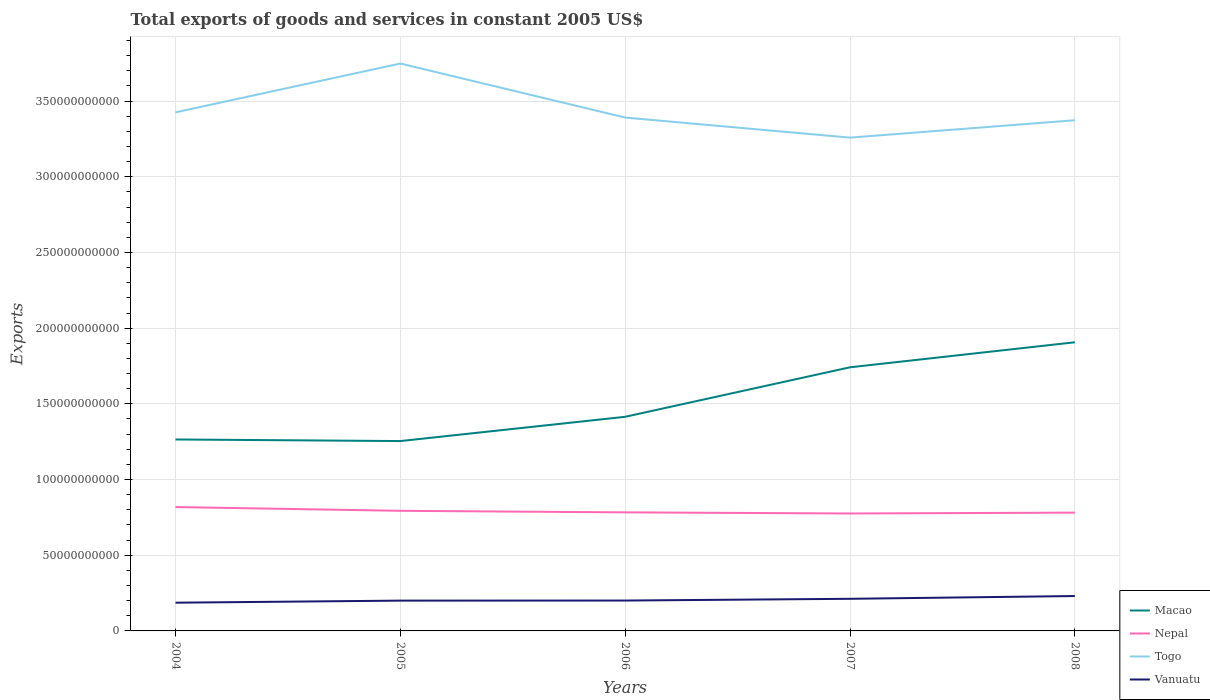Is the number of lines equal to the number of legend labels?
Your answer should be compact. Yes. Across all years, what is the maximum total exports of goods and services in Nepal?
Make the answer very short. 7.76e+1. In which year was the total exports of goods and services in Nepal maximum?
Keep it short and to the point. 2007. What is the total total exports of goods and services in Togo in the graph?
Ensure brevity in your answer.  1.33e+1. What is the difference between the highest and the second highest total exports of goods and services in Nepal?
Your response must be concise. 4.25e+09. What is the difference between the highest and the lowest total exports of goods and services in Vanuatu?
Provide a succinct answer. 2. How many years are there in the graph?
Offer a terse response. 5. What is the difference between two consecutive major ticks on the Y-axis?
Your answer should be very brief. 5.00e+1. Does the graph contain any zero values?
Provide a short and direct response. No. Where does the legend appear in the graph?
Offer a very short reply. Bottom right. How are the legend labels stacked?
Offer a very short reply. Vertical. What is the title of the graph?
Keep it short and to the point. Total exports of goods and services in constant 2005 US$. What is the label or title of the Y-axis?
Offer a terse response. Exports. What is the Exports of Macao in 2004?
Your response must be concise. 1.26e+11. What is the Exports of Nepal in 2004?
Provide a short and direct response. 8.18e+1. What is the Exports of Togo in 2004?
Make the answer very short. 3.43e+11. What is the Exports in Vanuatu in 2004?
Offer a terse response. 1.86e+1. What is the Exports of Macao in 2005?
Offer a very short reply. 1.25e+11. What is the Exports of Nepal in 2005?
Keep it short and to the point. 7.93e+1. What is the Exports in Togo in 2005?
Your answer should be compact. 3.75e+11. What is the Exports of Vanuatu in 2005?
Offer a very short reply. 2.00e+1. What is the Exports of Macao in 2006?
Your answer should be very brief. 1.41e+11. What is the Exports of Nepal in 2006?
Your answer should be compact. 7.83e+1. What is the Exports in Togo in 2006?
Provide a succinct answer. 3.39e+11. What is the Exports in Vanuatu in 2006?
Give a very brief answer. 2.01e+1. What is the Exports in Macao in 2007?
Ensure brevity in your answer.  1.74e+11. What is the Exports in Nepal in 2007?
Offer a very short reply. 7.76e+1. What is the Exports of Togo in 2007?
Your response must be concise. 3.26e+11. What is the Exports of Vanuatu in 2007?
Keep it short and to the point. 2.12e+1. What is the Exports of Macao in 2008?
Offer a terse response. 1.91e+11. What is the Exports of Nepal in 2008?
Provide a succinct answer. 7.81e+1. What is the Exports in Togo in 2008?
Offer a terse response. 3.37e+11. What is the Exports in Vanuatu in 2008?
Your answer should be very brief. 2.31e+1. Across all years, what is the maximum Exports of Macao?
Your response must be concise. 1.91e+11. Across all years, what is the maximum Exports in Nepal?
Your response must be concise. 8.18e+1. Across all years, what is the maximum Exports in Togo?
Make the answer very short. 3.75e+11. Across all years, what is the maximum Exports of Vanuatu?
Give a very brief answer. 2.31e+1. Across all years, what is the minimum Exports of Macao?
Offer a very short reply. 1.25e+11. Across all years, what is the minimum Exports of Nepal?
Provide a short and direct response. 7.76e+1. Across all years, what is the minimum Exports of Togo?
Offer a very short reply. 3.26e+11. Across all years, what is the minimum Exports in Vanuatu?
Your answer should be compact. 1.86e+1. What is the total Exports of Macao in the graph?
Your answer should be compact. 7.58e+11. What is the total Exports in Nepal in the graph?
Your response must be concise. 3.95e+11. What is the total Exports in Togo in the graph?
Make the answer very short. 1.72e+12. What is the total Exports of Vanuatu in the graph?
Your answer should be very brief. 1.03e+11. What is the difference between the Exports in Macao in 2004 and that in 2005?
Provide a succinct answer. 1.05e+09. What is the difference between the Exports in Nepal in 2004 and that in 2005?
Ensure brevity in your answer.  2.48e+09. What is the difference between the Exports in Togo in 2004 and that in 2005?
Make the answer very short. -3.22e+1. What is the difference between the Exports in Vanuatu in 2004 and that in 2005?
Your answer should be very brief. -1.37e+09. What is the difference between the Exports in Macao in 2004 and that in 2006?
Give a very brief answer. -1.50e+1. What is the difference between the Exports of Nepal in 2004 and that in 2006?
Make the answer very short. 3.51e+09. What is the difference between the Exports in Togo in 2004 and that in 2006?
Your answer should be very brief. 3.45e+09. What is the difference between the Exports in Vanuatu in 2004 and that in 2006?
Offer a terse response. -1.42e+09. What is the difference between the Exports of Macao in 2004 and that in 2007?
Provide a short and direct response. -4.77e+1. What is the difference between the Exports in Nepal in 2004 and that in 2007?
Provide a succinct answer. 4.25e+09. What is the difference between the Exports of Togo in 2004 and that in 2007?
Your answer should be compact. 1.67e+1. What is the difference between the Exports in Vanuatu in 2004 and that in 2007?
Offer a terse response. -2.58e+09. What is the difference between the Exports in Macao in 2004 and that in 2008?
Your answer should be very brief. -6.42e+1. What is the difference between the Exports of Nepal in 2004 and that in 2008?
Give a very brief answer. 3.69e+09. What is the difference between the Exports of Togo in 2004 and that in 2008?
Give a very brief answer. 5.23e+09. What is the difference between the Exports of Vanuatu in 2004 and that in 2008?
Ensure brevity in your answer.  -4.40e+09. What is the difference between the Exports of Macao in 2005 and that in 2006?
Offer a terse response. -1.60e+1. What is the difference between the Exports of Nepal in 2005 and that in 2006?
Your answer should be very brief. 1.03e+09. What is the difference between the Exports in Togo in 2005 and that in 2006?
Ensure brevity in your answer.  3.57e+1. What is the difference between the Exports of Vanuatu in 2005 and that in 2006?
Make the answer very short. -5.00e+07. What is the difference between the Exports of Macao in 2005 and that in 2007?
Provide a short and direct response. -4.87e+1. What is the difference between the Exports of Nepal in 2005 and that in 2007?
Your answer should be compact. 1.77e+09. What is the difference between the Exports of Togo in 2005 and that in 2007?
Your response must be concise. 4.90e+1. What is the difference between the Exports in Vanuatu in 2005 and that in 2007?
Provide a short and direct response. -1.21e+09. What is the difference between the Exports of Macao in 2005 and that in 2008?
Ensure brevity in your answer.  -6.53e+1. What is the difference between the Exports of Nepal in 2005 and that in 2008?
Your answer should be very brief. 1.20e+09. What is the difference between the Exports of Togo in 2005 and that in 2008?
Your answer should be compact. 3.75e+1. What is the difference between the Exports in Vanuatu in 2005 and that in 2008?
Offer a very short reply. -3.04e+09. What is the difference between the Exports of Macao in 2006 and that in 2007?
Make the answer very short. -3.27e+1. What is the difference between the Exports of Nepal in 2006 and that in 2007?
Make the answer very short. 7.40e+08. What is the difference between the Exports in Togo in 2006 and that in 2007?
Keep it short and to the point. 1.33e+1. What is the difference between the Exports in Vanuatu in 2006 and that in 2007?
Provide a short and direct response. -1.16e+09. What is the difference between the Exports in Macao in 2006 and that in 2008?
Your response must be concise. -4.92e+1. What is the difference between the Exports of Nepal in 2006 and that in 2008?
Your response must be concise. 1.76e+08. What is the difference between the Exports of Togo in 2006 and that in 2008?
Your response must be concise. 1.77e+09. What is the difference between the Exports in Vanuatu in 2006 and that in 2008?
Offer a very short reply. -2.99e+09. What is the difference between the Exports of Macao in 2007 and that in 2008?
Give a very brief answer. -1.65e+1. What is the difference between the Exports in Nepal in 2007 and that in 2008?
Offer a very short reply. -5.64e+08. What is the difference between the Exports of Togo in 2007 and that in 2008?
Give a very brief answer. -1.15e+1. What is the difference between the Exports in Vanuatu in 2007 and that in 2008?
Offer a very short reply. -1.83e+09. What is the difference between the Exports of Macao in 2004 and the Exports of Nepal in 2005?
Keep it short and to the point. 4.71e+1. What is the difference between the Exports of Macao in 2004 and the Exports of Togo in 2005?
Your response must be concise. -2.48e+11. What is the difference between the Exports of Macao in 2004 and the Exports of Vanuatu in 2005?
Offer a terse response. 1.06e+11. What is the difference between the Exports in Nepal in 2004 and the Exports in Togo in 2005?
Provide a succinct answer. -2.93e+11. What is the difference between the Exports in Nepal in 2004 and the Exports in Vanuatu in 2005?
Your answer should be compact. 6.18e+1. What is the difference between the Exports of Togo in 2004 and the Exports of Vanuatu in 2005?
Provide a short and direct response. 3.23e+11. What is the difference between the Exports in Macao in 2004 and the Exports in Nepal in 2006?
Offer a terse response. 4.82e+1. What is the difference between the Exports in Macao in 2004 and the Exports in Togo in 2006?
Your response must be concise. -2.13e+11. What is the difference between the Exports of Macao in 2004 and the Exports of Vanuatu in 2006?
Give a very brief answer. 1.06e+11. What is the difference between the Exports of Nepal in 2004 and the Exports of Togo in 2006?
Make the answer very short. -2.57e+11. What is the difference between the Exports of Nepal in 2004 and the Exports of Vanuatu in 2006?
Provide a short and direct response. 6.18e+1. What is the difference between the Exports of Togo in 2004 and the Exports of Vanuatu in 2006?
Offer a very short reply. 3.23e+11. What is the difference between the Exports of Macao in 2004 and the Exports of Nepal in 2007?
Offer a terse response. 4.89e+1. What is the difference between the Exports in Macao in 2004 and the Exports in Togo in 2007?
Keep it short and to the point. -1.99e+11. What is the difference between the Exports in Macao in 2004 and the Exports in Vanuatu in 2007?
Offer a very short reply. 1.05e+11. What is the difference between the Exports of Nepal in 2004 and the Exports of Togo in 2007?
Provide a succinct answer. -2.44e+11. What is the difference between the Exports of Nepal in 2004 and the Exports of Vanuatu in 2007?
Offer a terse response. 6.06e+1. What is the difference between the Exports of Togo in 2004 and the Exports of Vanuatu in 2007?
Keep it short and to the point. 3.21e+11. What is the difference between the Exports in Macao in 2004 and the Exports in Nepal in 2008?
Your answer should be compact. 4.83e+1. What is the difference between the Exports in Macao in 2004 and the Exports in Togo in 2008?
Ensure brevity in your answer.  -2.11e+11. What is the difference between the Exports in Macao in 2004 and the Exports in Vanuatu in 2008?
Your response must be concise. 1.03e+11. What is the difference between the Exports in Nepal in 2004 and the Exports in Togo in 2008?
Make the answer very short. -2.56e+11. What is the difference between the Exports in Nepal in 2004 and the Exports in Vanuatu in 2008?
Your answer should be very brief. 5.88e+1. What is the difference between the Exports of Togo in 2004 and the Exports of Vanuatu in 2008?
Your answer should be compact. 3.20e+11. What is the difference between the Exports of Macao in 2005 and the Exports of Nepal in 2006?
Provide a succinct answer. 4.71e+1. What is the difference between the Exports in Macao in 2005 and the Exports in Togo in 2006?
Offer a very short reply. -2.14e+11. What is the difference between the Exports in Macao in 2005 and the Exports in Vanuatu in 2006?
Provide a short and direct response. 1.05e+11. What is the difference between the Exports of Nepal in 2005 and the Exports of Togo in 2006?
Keep it short and to the point. -2.60e+11. What is the difference between the Exports of Nepal in 2005 and the Exports of Vanuatu in 2006?
Your answer should be compact. 5.93e+1. What is the difference between the Exports of Togo in 2005 and the Exports of Vanuatu in 2006?
Provide a short and direct response. 3.55e+11. What is the difference between the Exports in Macao in 2005 and the Exports in Nepal in 2007?
Your answer should be very brief. 4.78e+1. What is the difference between the Exports in Macao in 2005 and the Exports in Togo in 2007?
Offer a very short reply. -2.00e+11. What is the difference between the Exports of Macao in 2005 and the Exports of Vanuatu in 2007?
Keep it short and to the point. 1.04e+11. What is the difference between the Exports of Nepal in 2005 and the Exports of Togo in 2007?
Give a very brief answer. -2.47e+11. What is the difference between the Exports of Nepal in 2005 and the Exports of Vanuatu in 2007?
Ensure brevity in your answer.  5.81e+1. What is the difference between the Exports of Togo in 2005 and the Exports of Vanuatu in 2007?
Provide a short and direct response. 3.54e+11. What is the difference between the Exports of Macao in 2005 and the Exports of Nepal in 2008?
Offer a very short reply. 4.73e+1. What is the difference between the Exports in Macao in 2005 and the Exports in Togo in 2008?
Your response must be concise. -2.12e+11. What is the difference between the Exports of Macao in 2005 and the Exports of Vanuatu in 2008?
Offer a terse response. 1.02e+11. What is the difference between the Exports in Nepal in 2005 and the Exports in Togo in 2008?
Keep it short and to the point. -2.58e+11. What is the difference between the Exports of Nepal in 2005 and the Exports of Vanuatu in 2008?
Provide a short and direct response. 5.63e+1. What is the difference between the Exports in Togo in 2005 and the Exports in Vanuatu in 2008?
Keep it short and to the point. 3.52e+11. What is the difference between the Exports of Macao in 2006 and the Exports of Nepal in 2007?
Your response must be concise. 6.39e+1. What is the difference between the Exports of Macao in 2006 and the Exports of Togo in 2007?
Make the answer very short. -1.84e+11. What is the difference between the Exports of Macao in 2006 and the Exports of Vanuatu in 2007?
Your response must be concise. 1.20e+11. What is the difference between the Exports in Nepal in 2006 and the Exports in Togo in 2007?
Ensure brevity in your answer.  -2.48e+11. What is the difference between the Exports in Nepal in 2006 and the Exports in Vanuatu in 2007?
Make the answer very short. 5.71e+1. What is the difference between the Exports of Togo in 2006 and the Exports of Vanuatu in 2007?
Make the answer very short. 3.18e+11. What is the difference between the Exports of Macao in 2006 and the Exports of Nepal in 2008?
Your response must be concise. 6.33e+1. What is the difference between the Exports of Macao in 2006 and the Exports of Togo in 2008?
Your answer should be very brief. -1.96e+11. What is the difference between the Exports in Macao in 2006 and the Exports in Vanuatu in 2008?
Make the answer very short. 1.18e+11. What is the difference between the Exports in Nepal in 2006 and the Exports in Togo in 2008?
Your answer should be very brief. -2.59e+11. What is the difference between the Exports in Nepal in 2006 and the Exports in Vanuatu in 2008?
Your answer should be compact. 5.53e+1. What is the difference between the Exports in Togo in 2006 and the Exports in Vanuatu in 2008?
Keep it short and to the point. 3.16e+11. What is the difference between the Exports in Macao in 2007 and the Exports in Nepal in 2008?
Ensure brevity in your answer.  9.60e+1. What is the difference between the Exports in Macao in 2007 and the Exports in Togo in 2008?
Give a very brief answer. -1.63e+11. What is the difference between the Exports of Macao in 2007 and the Exports of Vanuatu in 2008?
Provide a short and direct response. 1.51e+11. What is the difference between the Exports of Nepal in 2007 and the Exports of Togo in 2008?
Keep it short and to the point. -2.60e+11. What is the difference between the Exports of Nepal in 2007 and the Exports of Vanuatu in 2008?
Offer a terse response. 5.45e+1. What is the difference between the Exports in Togo in 2007 and the Exports in Vanuatu in 2008?
Your response must be concise. 3.03e+11. What is the average Exports of Macao per year?
Provide a succinct answer. 1.52e+11. What is the average Exports of Nepal per year?
Keep it short and to the point. 7.90e+1. What is the average Exports in Togo per year?
Make the answer very short. 3.44e+11. What is the average Exports in Vanuatu per year?
Make the answer very short. 2.06e+1. In the year 2004, what is the difference between the Exports in Macao and Exports in Nepal?
Keep it short and to the point. 4.46e+1. In the year 2004, what is the difference between the Exports in Macao and Exports in Togo?
Provide a succinct answer. -2.16e+11. In the year 2004, what is the difference between the Exports in Macao and Exports in Vanuatu?
Offer a terse response. 1.08e+11. In the year 2004, what is the difference between the Exports in Nepal and Exports in Togo?
Keep it short and to the point. -2.61e+11. In the year 2004, what is the difference between the Exports of Nepal and Exports of Vanuatu?
Make the answer very short. 6.32e+1. In the year 2004, what is the difference between the Exports of Togo and Exports of Vanuatu?
Give a very brief answer. 3.24e+11. In the year 2005, what is the difference between the Exports of Macao and Exports of Nepal?
Offer a terse response. 4.61e+1. In the year 2005, what is the difference between the Exports in Macao and Exports in Togo?
Provide a short and direct response. -2.49e+11. In the year 2005, what is the difference between the Exports of Macao and Exports of Vanuatu?
Offer a very short reply. 1.05e+11. In the year 2005, what is the difference between the Exports in Nepal and Exports in Togo?
Provide a succinct answer. -2.95e+11. In the year 2005, what is the difference between the Exports in Nepal and Exports in Vanuatu?
Provide a short and direct response. 5.93e+1. In the year 2005, what is the difference between the Exports in Togo and Exports in Vanuatu?
Ensure brevity in your answer.  3.55e+11. In the year 2006, what is the difference between the Exports of Macao and Exports of Nepal?
Provide a succinct answer. 6.31e+1. In the year 2006, what is the difference between the Exports in Macao and Exports in Togo?
Offer a terse response. -1.98e+11. In the year 2006, what is the difference between the Exports of Macao and Exports of Vanuatu?
Your response must be concise. 1.21e+11. In the year 2006, what is the difference between the Exports of Nepal and Exports of Togo?
Keep it short and to the point. -2.61e+11. In the year 2006, what is the difference between the Exports of Nepal and Exports of Vanuatu?
Offer a very short reply. 5.83e+1. In the year 2006, what is the difference between the Exports in Togo and Exports in Vanuatu?
Your answer should be compact. 3.19e+11. In the year 2007, what is the difference between the Exports in Macao and Exports in Nepal?
Provide a short and direct response. 9.66e+1. In the year 2007, what is the difference between the Exports of Macao and Exports of Togo?
Give a very brief answer. -1.52e+11. In the year 2007, what is the difference between the Exports in Macao and Exports in Vanuatu?
Keep it short and to the point. 1.53e+11. In the year 2007, what is the difference between the Exports in Nepal and Exports in Togo?
Offer a terse response. -2.48e+11. In the year 2007, what is the difference between the Exports of Nepal and Exports of Vanuatu?
Provide a short and direct response. 5.64e+1. In the year 2007, what is the difference between the Exports in Togo and Exports in Vanuatu?
Provide a succinct answer. 3.05e+11. In the year 2008, what is the difference between the Exports in Macao and Exports in Nepal?
Offer a very short reply. 1.13e+11. In the year 2008, what is the difference between the Exports in Macao and Exports in Togo?
Offer a terse response. -1.47e+11. In the year 2008, what is the difference between the Exports of Macao and Exports of Vanuatu?
Your answer should be very brief. 1.68e+11. In the year 2008, what is the difference between the Exports of Nepal and Exports of Togo?
Your response must be concise. -2.59e+11. In the year 2008, what is the difference between the Exports in Nepal and Exports in Vanuatu?
Ensure brevity in your answer.  5.51e+1. In the year 2008, what is the difference between the Exports in Togo and Exports in Vanuatu?
Provide a succinct answer. 3.14e+11. What is the ratio of the Exports of Macao in 2004 to that in 2005?
Your response must be concise. 1.01. What is the ratio of the Exports in Nepal in 2004 to that in 2005?
Your answer should be compact. 1.03. What is the ratio of the Exports of Togo in 2004 to that in 2005?
Make the answer very short. 0.91. What is the ratio of the Exports of Vanuatu in 2004 to that in 2005?
Your response must be concise. 0.93. What is the ratio of the Exports of Macao in 2004 to that in 2006?
Ensure brevity in your answer.  0.89. What is the ratio of the Exports in Nepal in 2004 to that in 2006?
Your response must be concise. 1.04. What is the ratio of the Exports of Togo in 2004 to that in 2006?
Provide a short and direct response. 1.01. What is the ratio of the Exports of Vanuatu in 2004 to that in 2006?
Make the answer very short. 0.93. What is the ratio of the Exports in Macao in 2004 to that in 2007?
Keep it short and to the point. 0.73. What is the ratio of the Exports in Nepal in 2004 to that in 2007?
Ensure brevity in your answer.  1.05. What is the ratio of the Exports in Togo in 2004 to that in 2007?
Make the answer very short. 1.05. What is the ratio of the Exports in Vanuatu in 2004 to that in 2007?
Your answer should be compact. 0.88. What is the ratio of the Exports in Macao in 2004 to that in 2008?
Give a very brief answer. 0.66. What is the ratio of the Exports of Nepal in 2004 to that in 2008?
Your answer should be very brief. 1.05. What is the ratio of the Exports of Togo in 2004 to that in 2008?
Provide a short and direct response. 1.02. What is the ratio of the Exports of Vanuatu in 2004 to that in 2008?
Provide a short and direct response. 0.81. What is the ratio of the Exports of Macao in 2005 to that in 2006?
Your answer should be very brief. 0.89. What is the ratio of the Exports in Nepal in 2005 to that in 2006?
Give a very brief answer. 1.01. What is the ratio of the Exports of Togo in 2005 to that in 2006?
Make the answer very short. 1.11. What is the ratio of the Exports in Macao in 2005 to that in 2007?
Keep it short and to the point. 0.72. What is the ratio of the Exports in Nepal in 2005 to that in 2007?
Your response must be concise. 1.02. What is the ratio of the Exports of Togo in 2005 to that in 2007?
Offer a terse response. 1.15. What is the ratio of the Exports of Vanuatu in 2005 to that in 2007?
Your response must be concise. 0.94. What is the ratio of the Exports of Macao in 2005 to that in 2008?
Your answer should be compact. 0.66. What is the ratio of the Exports of Nepal in 2005 to that in 2008?
Provide a succinct answer. 1.02. What is the ratio of the Exports of Togo in 2005 to that in 2008?
Your answer should be very brief. 1.11. What is the ratio of the Exports in Vanuatu in 2005 to that in 2008?
Your answer should be very brief. 0.87. What is the ratio of the Exports in Macao in 2006 to that in 2007?
Your answer should be compact. 0.81. What is the ratio of the Exports of Nepal in 2006 to that in 2007?
Make the answer very short. 1.01. What is the ratio of the Exports in Togo in 2006 to that in 2007?
Keep it short and to the point. 1.04. What is the ratio of the Exports of Vanuatu in 2006 to that in 2007?
Give a very brief answer. 0.95. What is the ratio of the Exports in Macao in 2006 to that in 2008?
Give a very brief answer. 0.74. What is the ratio of the Exports in Togo in 2006 to that in 2008?
Provide a succinct answer. 1.01. What is the ratio of the Exports in Vanuatu in 2006 to that in 2008?
Provide a short and direct response. 0.87. What is the ratio of the Exports in Macao in 2007 to that in 2008?
Provide a succinct answer. 0.91. What is the ratio of the Exports of Nepal in 2007 to that in 2008?
Provide a short and direct response. 0.99. What is the ratio of the Exports of Togo in 2007 to that in 2008?
Make the answer very short. 0.97. What is the ratio of the Exports in Vanuatu in 2007 to that in 2008?
Provide a succinct answer. 0.92. What is the difference between the highest and the second highest Exports of Macao?
Provide a short and direct response. 1.65e+1. What is the difference between the highest and the second highest Exports of Nepal?
Provide a short and direct response. 2.48e+09. What is the difference between the highest and the second highest Exports in Togo?
Keep it short and to the point. 3.22e+1. What is the difference between the highest and the second highest Exports of Vanuatu?
Your response must be concise. 1.83e+09. What is the difference between the highest and the lowest Exports of Macao?
Offer a very short reply. 6.53e+1. What is the difference between the highest and the lowest Exports of Nepal?
Provide a short and direct response. 4.25e+09. What is the difference between the highest and the lowest Exports in Togo?
Make the answer very short. 4.90e+1. What is the difference between the highest and the lowest Exports of Vanuatu?
Provide a succinct answer. 4.40e+09. 